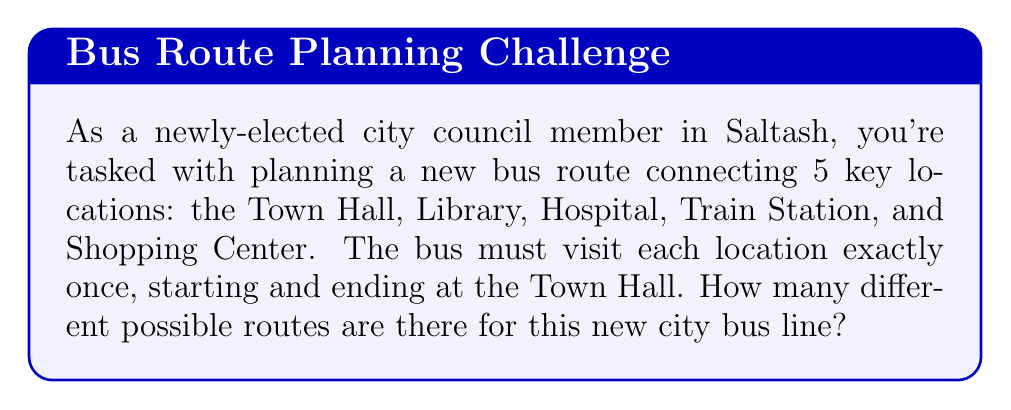Can you answer this question? Let's approach this step-by-step:

1) This problem is essentially asking for the number of permutations of 4 locations (excluding the Town Hall, as it's fixed as the start and end point).

2) We can use the formula for permutations:
   $$ P(n) = n! $$
   where $n$ is the number of elements to be permuted.

3) In this case, $n = 4$ (Library, Hospital, Train Station, and Shopping Center).

4) Therefore, the number of possible routes is:
   $$ P(4) = 4! = 4 \times 3 \times 2 \times 1 = 24 $$

5) To visualize this, we can think of it as:
   - We have 4 choices for the first stop after the Town Hall
   - Then 3 choices for the second stop
   - 2 choices for the third stop
   - Only 1 choice left for the last stop before returning to the Town Hall

6) Multiplying these choices together: $4 \times 3 \times 2 \times 1 = 24$

This gives us the total number of possible routes for the new city bus line.
Answer: 24 